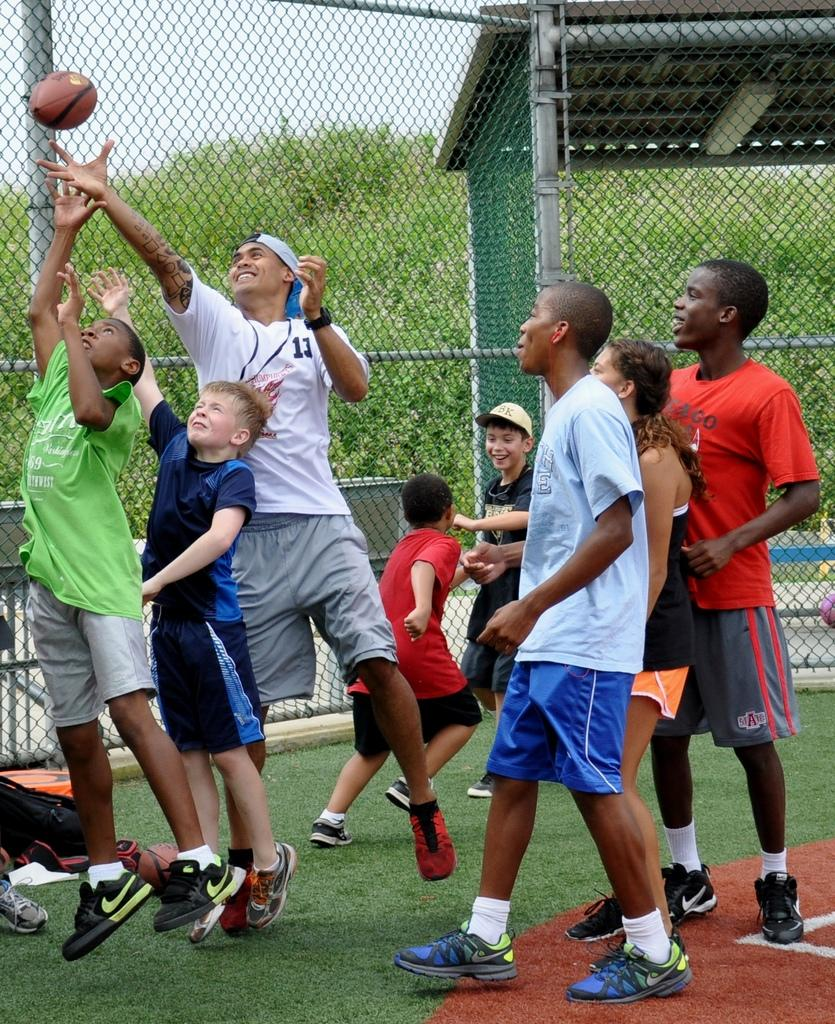Who is present in the image? There is a person in the image. Who else is present in the image besides the person? There are kids in the image. What is the setting of the image? The person and kids are in front of a mesh. What can be seen in the top left of the image? There is a ball in the top left of the image. What is located in the middle of the image? There is a shelter and plants in the middle of the image. What type of sea creature can be seen crawling out of the water in the image? There is no sea or sea creature present in the image. What sense is being stimulated by the dock in the image? There is no dock present in the image, so it is not possible to determine which sense might be stimulated. 